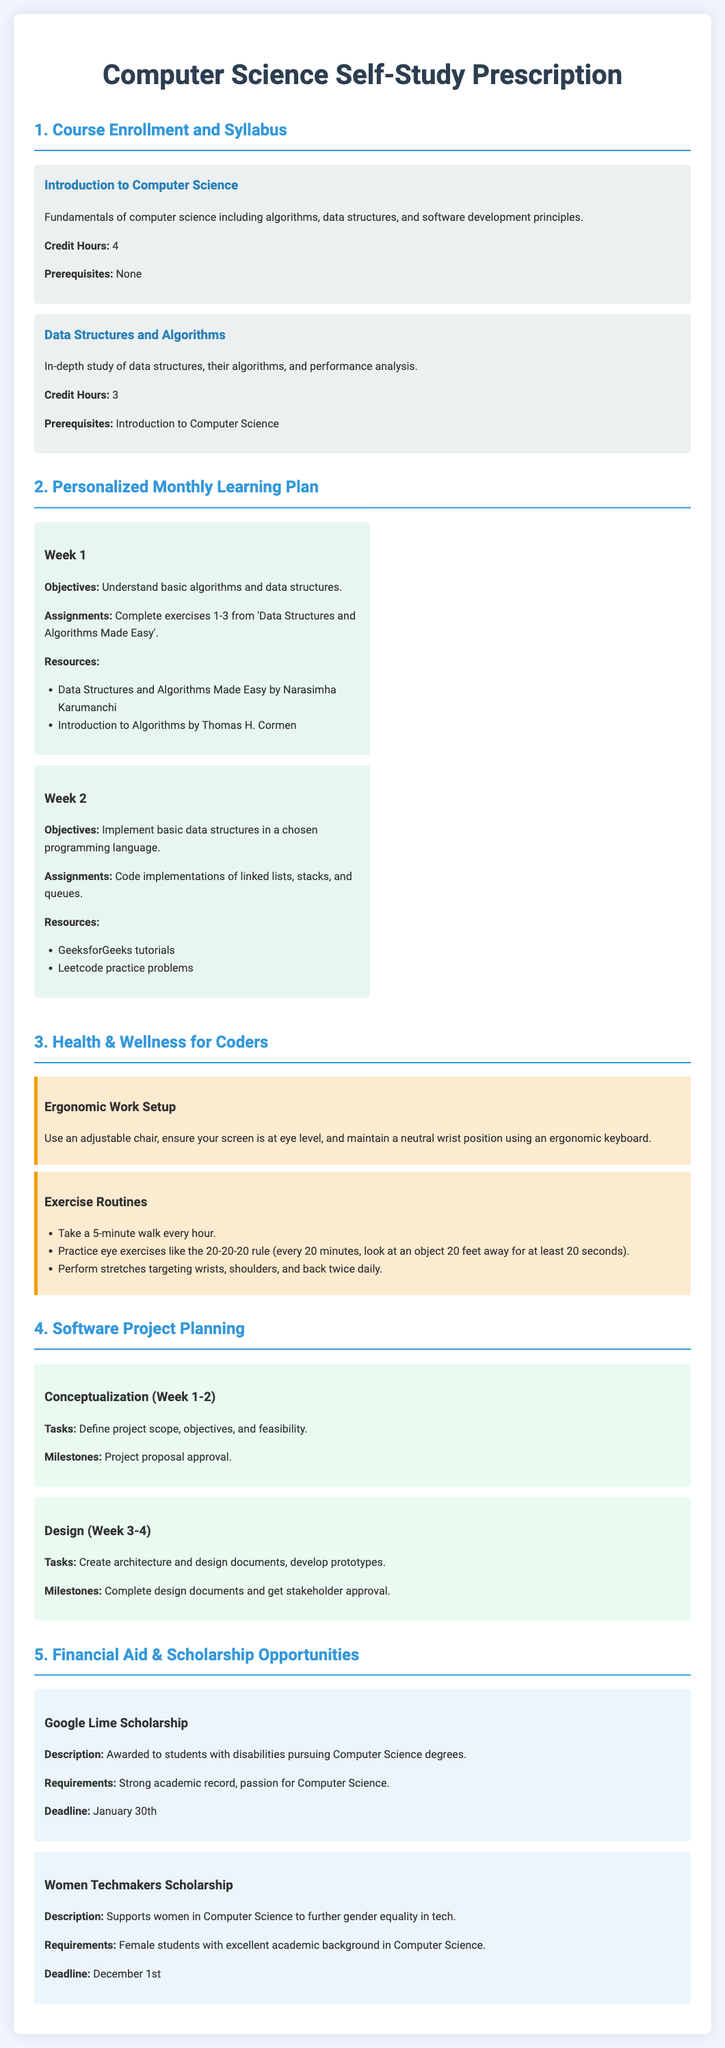What is the credit hours for Data Structures and Algorithms? The credit hours for Data Structures and Algorithms is specified just below the course title in the document.
Answer: 3 What is a prerequisite for the Introduction to Computer Science course? The prerequisite for the Introduction to Computer Science course is listed in the course details.
Answer: None What is the objective for Week 1 in the Personalized Monthly Learning Plan? The objective for Week 1 can be found in the corresponding section of the document.
Answer: Understand basic algorithms and data structures What is the deadline for the Women Techmakers Scholarship? The deadline for the Women Techmakers Scholarship is clearly stated in the scholarship description.
Answer: December 1st What does the ergonomic work setup recommend for screen placement? The recommendation can be found within the Health & Wellness section of the document.
Answer: Eye level What are the tasks in the Conceptualization stage of Software Project Planning? The tasks for the Conceptualization stage are outlined in the project planning section of the document.
Answer: Define project scope, objectives, and feasibility How many exercises need to be completed in Week 1? The number of exercises required for Week 1 is mentioned in the Personalized Monthly Learning Plan schedule.
Answer: 3 What type of students is eligible for the Google Lime Scholarship? The eligibility criteria for the Google Lime Scholarship is detailed within the scholarship section of the document.
Answer: Students with disabilities What should be done every hour according to the exercise routines? The exercise routines listed in the Health & Wellness section direct specific actions to be taken every hour.
Answer: Take a 5-minute walk 